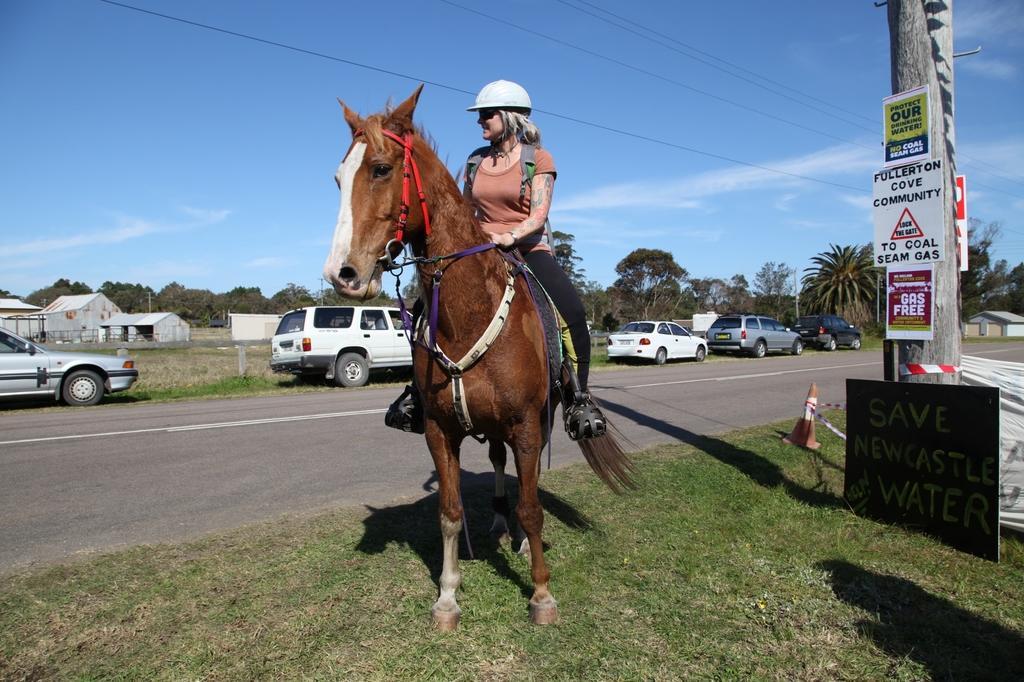How would you summarize this image in a sentence or two? In the image we can see there is a woman who is sitting on horse and the horse is standing on the road and cars are parked on the road. 